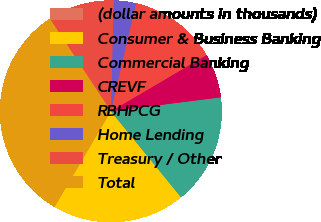Convert chart to OTSL. <chart><loc_0><loc_0><loc_500><loc_500><pie_chart><fcel>(dollar amounts in thousands)<fcel>Consumer & Business Banking<fcel>Commercial Banking<fcel>CREVF<fcel>RBHPCG<fcel>Home Lending<fcel>Treasury / Other<fcel>Total<nl><fcel>0.0%<fcel>19.35%<fcel>16.13%<fcel>6.45%<fcel>12.9%<fcel>3.23%<fcel>9.68%<fcel>32.26%<nl></chart> 